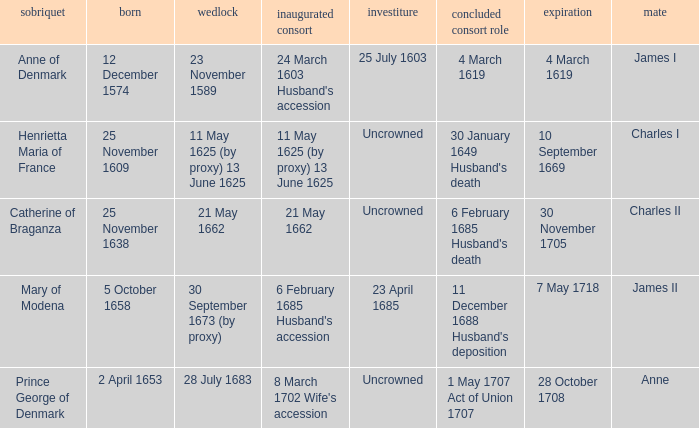On what date did James II take a consort? 6 February 1685 Husband's accession. 